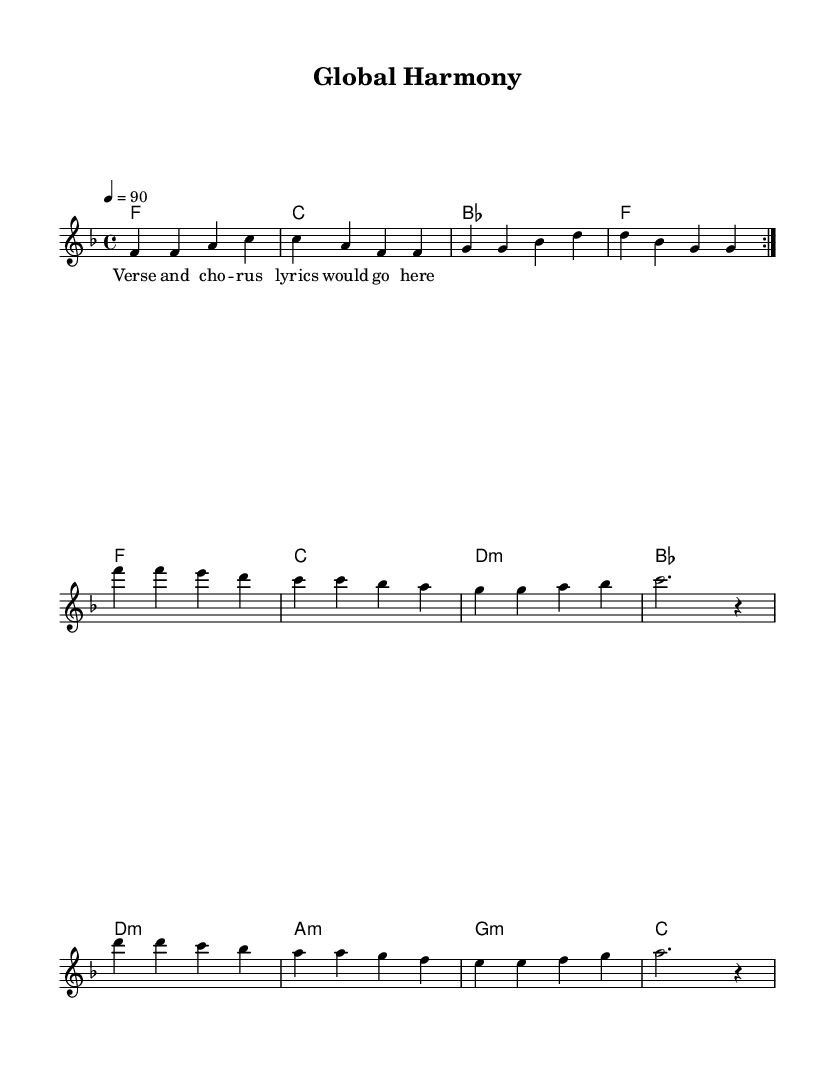What is the key signature of this music? The key signature is F major, which has one flat (B).
Answer: F major What is the time signature of this piece? The time signature is 4/4, indicating four beats per measure.
Answer: 4/4 What is the tempo marking of this music? The tempo marking indicates a speed of 90 beats per minute.
Answer: 90 How many volta sections are present in the melody? The melody has 2 volta sections, as indicated by the repeat markings.
Answer: 2 What are the primary chords used in the harmonic progression? The primary chords are F, C, B flat, and D minor.
Answer: F, C, B flat, D minor Why is the song categorized as Rhythm and Blues? The song incorporates elements typical of Rhythm and Blues, such as a call-and-response structure and soulful melodies.
Answer: Call-and-response structure What is the significance of the lyrics in this piece? The lyrics emphasize themes of international diplomacy and cultural exchange, capturing the essence of modern R&B content.
Answer: International diplomacy 